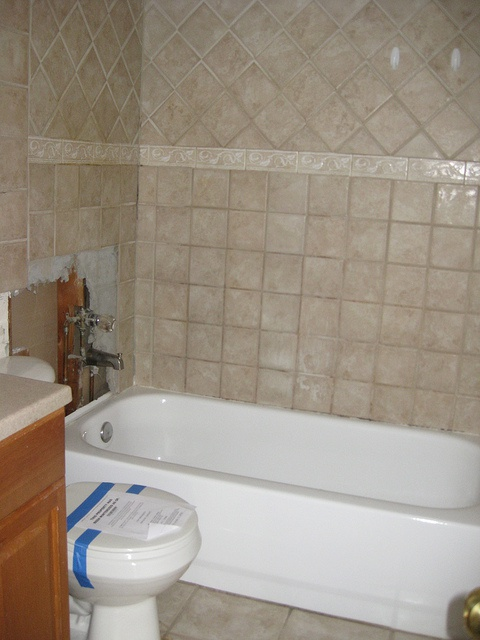Describe the objects in this image and their specific colors. I can see toilet in gray, darkgray, lightgray, and blue tones and sink in gray, darkgray, and tan tones in this image. 